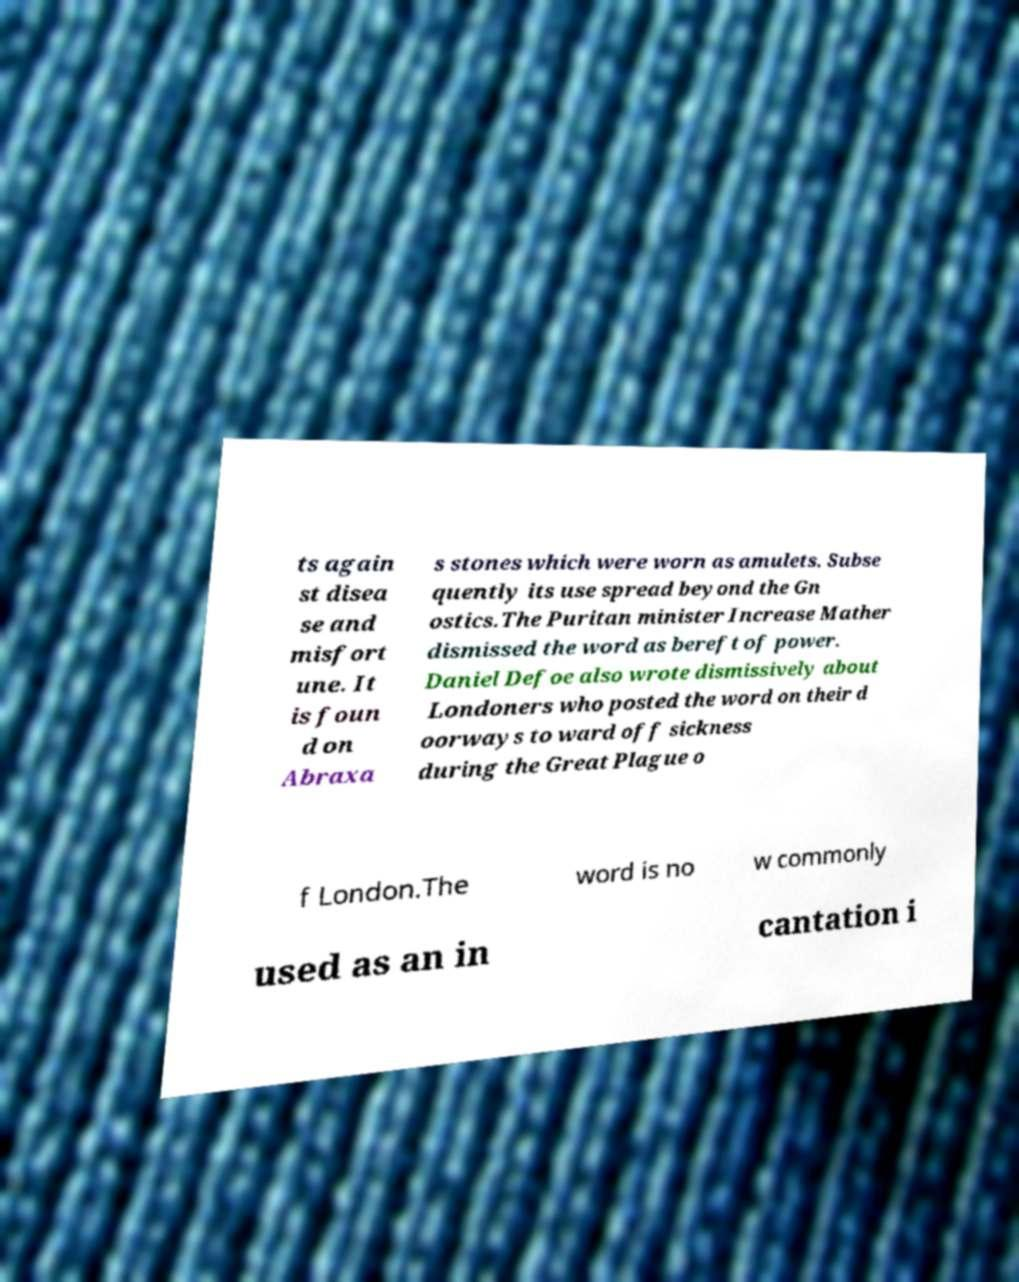Could you assist in decoding the text presented in this image and type it out clearly? ts again st disea se and misfort une. It is foun d on Abraxa s stones which were worn as amulets. Subse quently its use spread beyond the Gn ostics.The Puritan minister Increase Mather dismissed the word as bereft of power. Daniel Defoe also wrote dismissively about Londoners who posted the word on their d oorways to ward off sickness during the Great Plague o f London.The word is no w commonly used as an in cantation i 